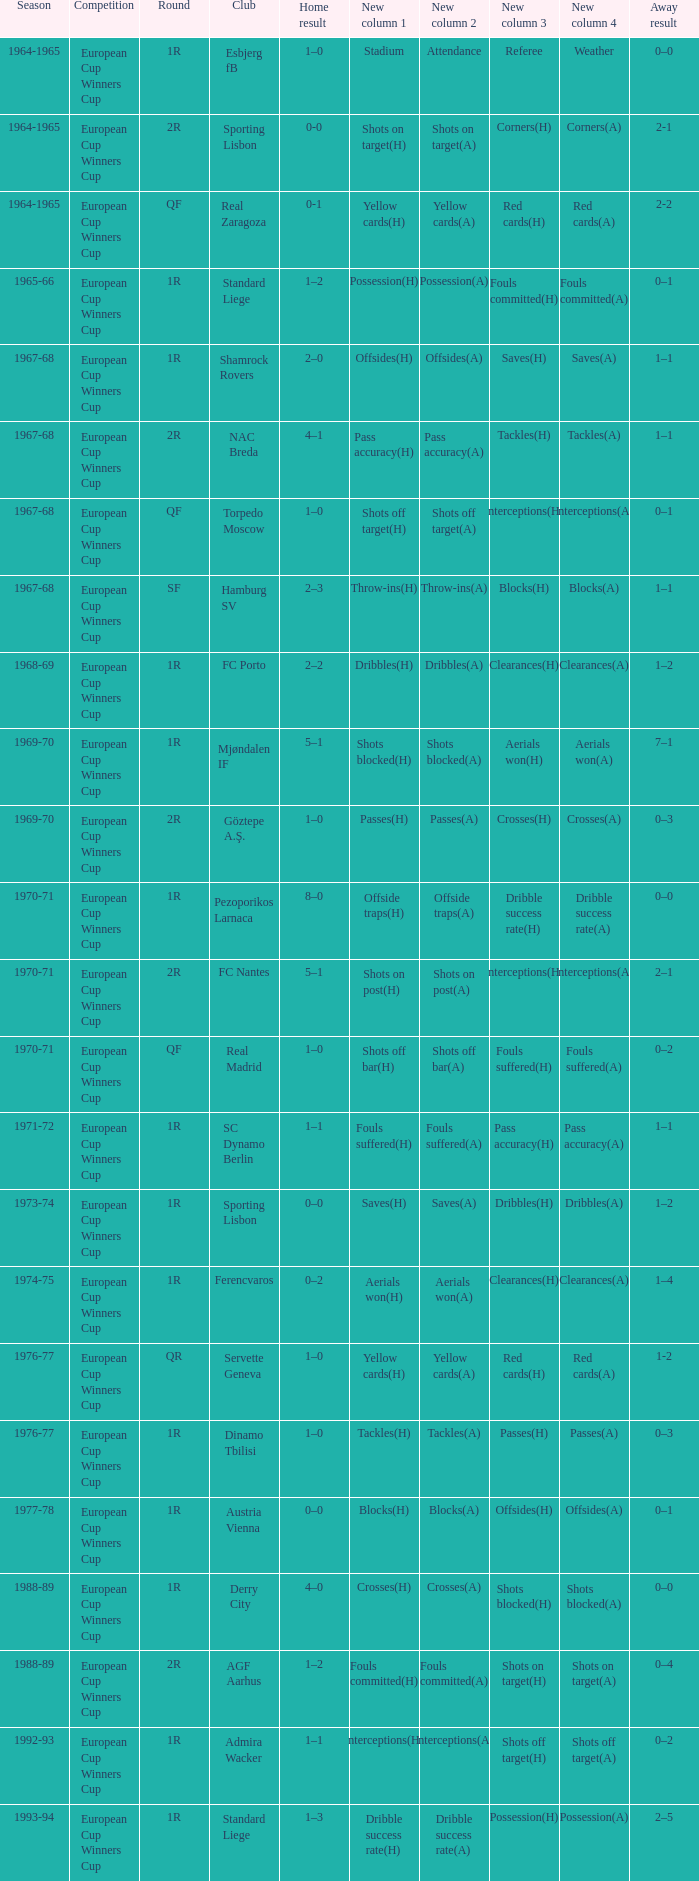Away result of 1–1, and a Round of 1r, and a Season of 1967-68 involves what club? Shamrock Rovers. 